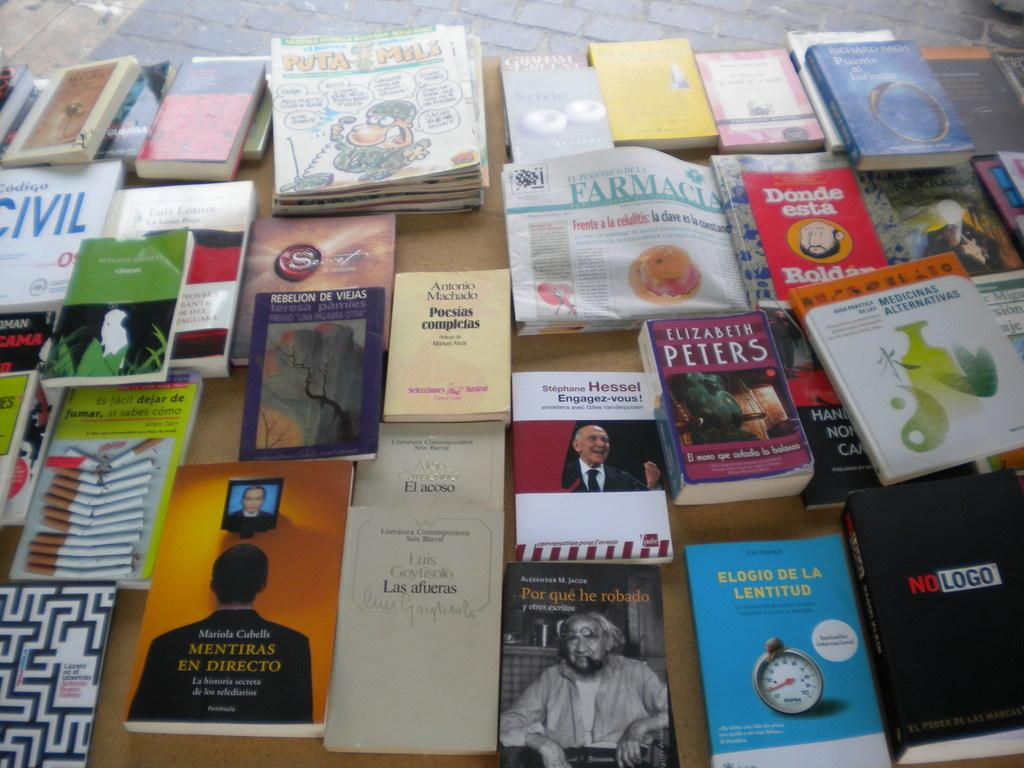<image>
Provide a brief description of the given image. Many books are lying on a table with a yellow one in the center written by Antonio Machado titled Pocsias complesas. 